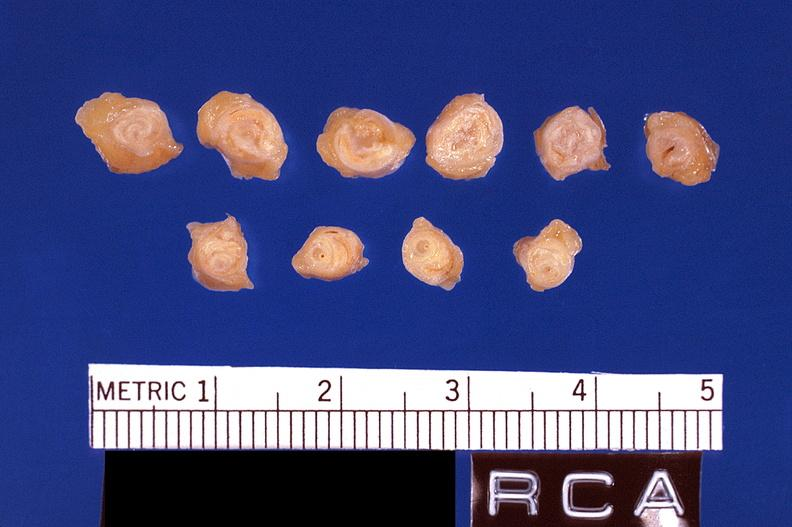s cardiovascular present?
Answer the question using a single word or phrase. Yes 